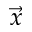Convert formula to latex. <formula><loc_0><loc_0><loc_500><loc_500>\vec { x }</formula> 